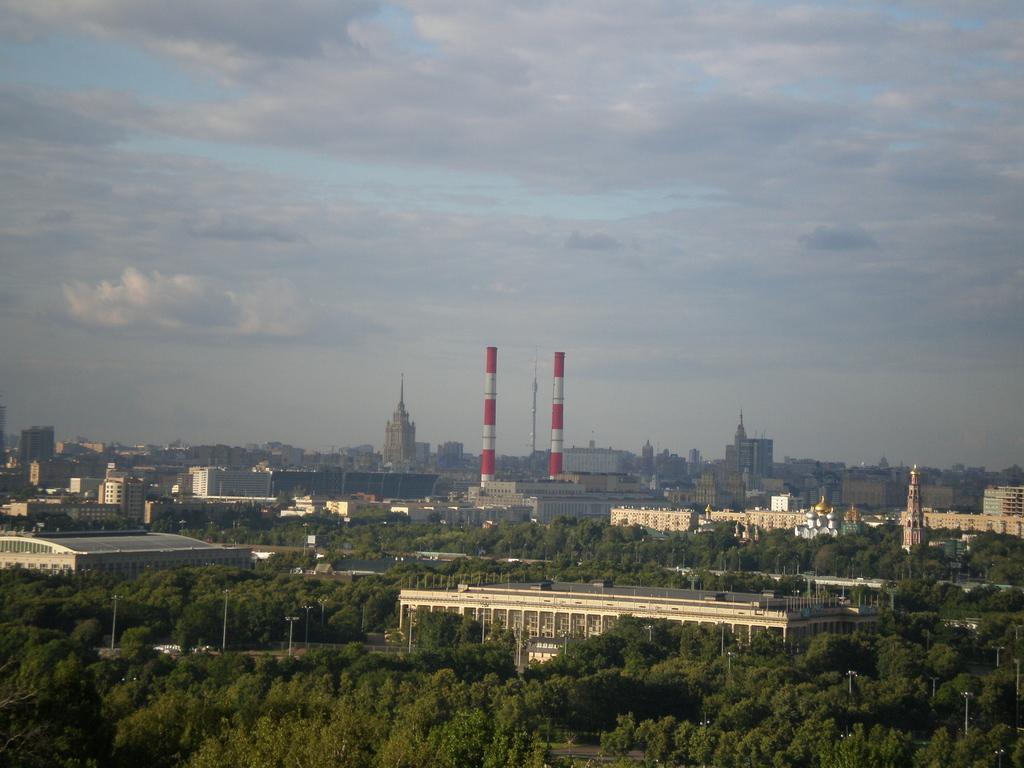How would you summarize this image in a sentence or two? In this image I can see many trees around the buildings. And there are two lighthouses in the back. I can also see the clouds and the sky in the back. 